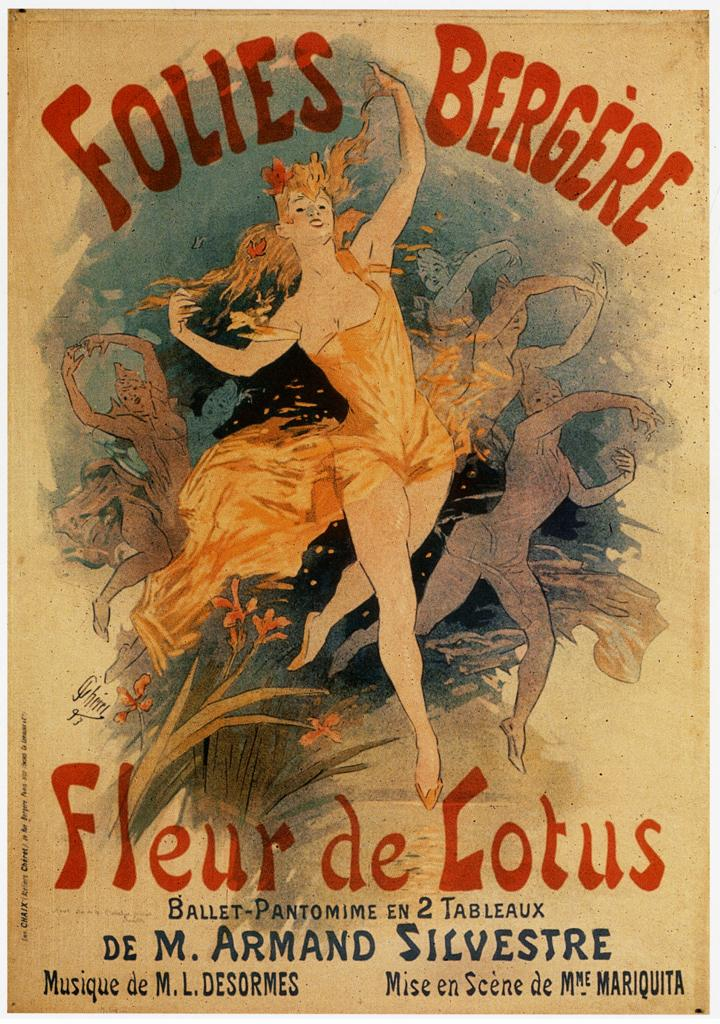<image>
Summarize the visual content of the image. A poster advertising the Folies Bergere Fleur de Lotus 